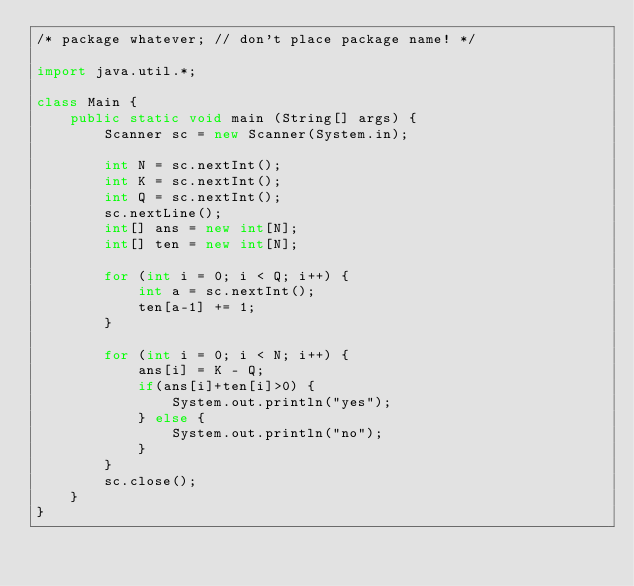<code> <loc_0><loc_0><loc_500><loc_500><_Java_>/* package whatever; // don't place package name! */

import java.util.*;

class Main {
    public static void main (String[] args) {
        Scanner sc = new Scanner(System.in);

        int N = sc.nextInt();
        int K = sc.nextInt();
        int Q = sc.nextInt();
        sc.nextLine();
        int[] ans = new int[N];
        int[] ten = new int[N];

        for (int i = 0; i < Q; i++) {
            int a = sc.nextInt();
            ten[a-1] += 1; 
        }
        
        for (int i = 0; i < N; i++) {
            ans[i] = K - Q;
            if(ans[i]+ten[i]>0) {
                System.out.println("yes");
            } else {
                System.out.println("no");
            }
        }
        sc.close();
    }
}</code> 